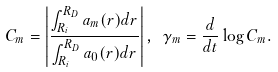Convert formula to latex. <formula><loc_0><loc_0><loc_500><loc_500>C _ { m } = \left | \frac { \int _ { R _ { i } } ^ { R _ { D } } a _ { m } ( r ) d r } { \int _ { R _ { i } } ^ { R _ { D } } a _ { 0 } ( r ) d r } \right | , \ \gamma _ { m } = \frac { d } { d t } \log C _ { m } .</formula> 